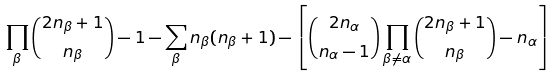Convert formula to latex. <formula><loc_0><loc_0><loc_500><loc_500>\prod _ { \beta } \binom { 2 n _ { \beta } + 1 } { n _ { \beta } } - 1 - \sum _ { \beta } n _ { \beta } ( n _ { \beta } + 1 ) - \left [ \binom { 2 n _ { \alpha } } { n _ { \alpha } - 1 } \prod _ { \beta \neq \alpha } \binom { 2 n _ { \beta } + 1 } { n _ { \beta } } - n _ { \alpha } \right ]</formula> 